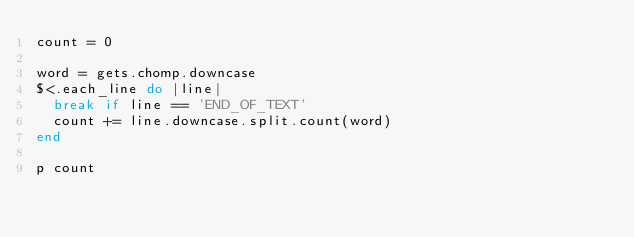Convert code to text. <code><loc_0><loc_0><loc_500><loc_500><_Ruby_>count = 0

word = gets.chomp.downcase
$<.each_line do |line|
	break if line == 'END_OF_TEXT'
	count += line.downcase.split.count(word)
end

p count</code> 